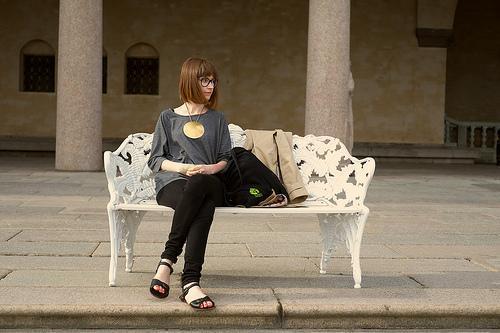How many benches are shown?
Give a very brief answer. 1. 